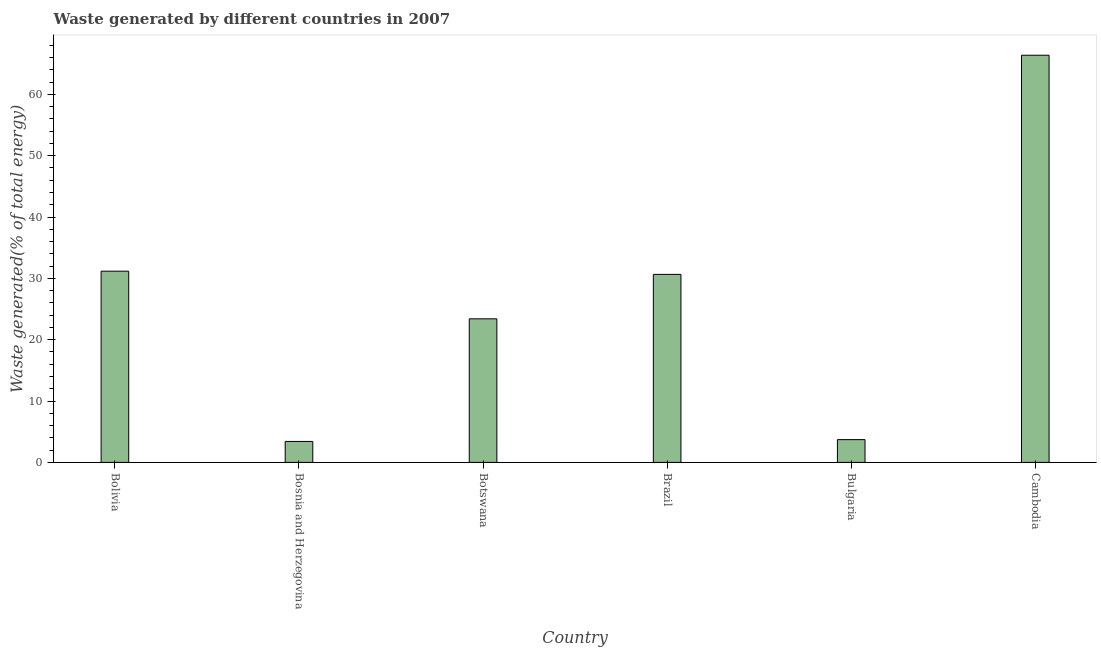Does the graph contain any zero values?
Your answer should be compact. No. Does the graph contain grids?
Provide a succinct answer. No. What is the title of the graph?
Make the answer very short. Waste generated by different countries in 2007. What is the label or title of the X-axis?
Provide a short and direct response. Country. What is the label or title of the Y-axis?
Your response must be concise. Waste generated(% of total energy). What is the amount of waste generated in Botswana?
Your response must be concise. 23.41. Across all countries, what is the maximum amount of waste generated?
Provide a short and direct response. 66.38. Across all countries, what is the minimum amount of waste generated?
Provide a succinct answer. 3.42. In which country was the amount of waste generated maximum?
Make the answer very short. Cambodia. In which country was the amount of waste generated minimum?
Make the answer very short. Bosnia and Herzegovina. What is the sum of the amount of waste generated?
Make the answer very short. 158.75. What is the difference between the amount of waste generated in Bosnia and Herzegovina and Bulgaria?
Your answer should be very brief. -0.29. What is the average amount of waste generated per country?
Provide a succinct answer. 26.46. What is the median amount of waste generated?
Offer a terse response. 27.03. In how many countries, is the amount of waste generated greater than 12 %?
Provide a short and direct response. 4. What is the ratio of the amount of waste generated in Bolivia to that in Bosnia and Herzegovina?
Provide a short and direct response. 9.13. Is the difference between the amount of waste generated in Brazil and Cambodia greater than the difference between any two countries?
Keep it short and to the point. No. What is the difference between the highest and the second highest amount of waste generated?
Make the answer very short. 35.2. What is the difference between the highest and the lowest amount of waste generated?
Keep it short and to the point. 62.97. Are the values on the major ticks of Y-axis written in scientific E-notation?
Make the answer very short. No. What is the Waste generated(% of total energy) of Bolivia?
Your response must be concise. 31.18. What is the Waste generated(% of total energy) of Bosnia and Herzegovina?
Offer a terse response. 3.42. What is the Waste generated(% of total energy) in Botswana?
Keep it short and to the point. 23.41. What is the Waste generated(% of total energy) of Brazil?
Make the answer very short. 30.65. What is the Waste generated(% of total energy) of Bulgaria?
Your answer should be compact. 3.71. What is the Waste generated(% of total energy) of Cambodia?
Keep it short and to the point. 66.38. What is the difference between the Waste generated(% of total energy) in Bolivia and Bosnia and Herzegovina?
Provide a succinct answer. 27.76. What is the difference between the Waste generated(% of total energy) in Bolivia and Botswana?
Your response must be concise. 7.77. What is the difference between the Waste generated(% of total energy) in Bolivia and Brazil?
Provide a short and direct response. 0.52. What is the difference between the Waste generated(% of total energy) in Bolivia and Bulgaria?
Make the answer very short. 27.47. What is the difference between the Waste generated(% of total energy) in Bolivia and Cambodia?
Your answer should be compact. -35.21. What is the difference between the Waste generated(% of total energy) in Bosnia and Herzegovina and Botswana?
Offer a terse response. -19.99. What is the difference between the Waste generated(% of total energy) in Bosnia and Herzegovina and Brazil?
Offer a very short reply. -27.24. What is the difference between the Waste generated(% of total energy) in Bosnia and Herzegovina and Bulgaria?
Keep it short and to the point. -0.29. What is the difference between the Waste generated(% of total energy) in Bosnia and Herzegovina and Cambodia?
Your answer should be very brief. -62.97. What is the difference between the Waste generated(% of total energy) in Botswana and Brazil?
Your answer should be very brief. -7.24. What is the difference between the Waste generated(% of total energy) in Botswana and Bulgaria?
Your answer should be very brief. 19.7. What is the difference between the Waste generated(% of total energy) in Botswana and Cambodia?
Make the answer very short. -42.97. What is the difference between the Waste generated(% of total energy) in Brazil and Bulgaria?
Your answer should be compact. 26.94. What is the difference between the Waste generated(% of total energy) in Brazil and Cambodia?
Give a very brief answer. -35.73. What is the difference between the Waste generated(% of total energy) in Bulgaria and Cambodia?
Offer a very short reply. -62.67. What is the ratio of the Waste generated(% of total energy) in Bolivia to that in Bosnia and Herzegovina?
Offer a very short reply. 9.13. What is the ratio of the Waste generated(% of total energy) in Bolivia to that in Botswana?
Offer a very short reply. 1.33. What is the ratio of the Waste generated(% of total energy) in Bolivia to that in Brazil?
Your answer should be very brief. 1.02. What is the ratio of the Waste generated(% of total energy) in Bolivia to that in Bulgaria?
Offer a very short reply. 8.4. What is the ratio of the Waste generated(% of total energy) in Bolivia to that in Cambodia?
Your answer should be very brief. 0.47. What is the ratio of the Waste generated(% of total energy) in Bosnia and Herzegovina to that in Botswana?
Keep it short and to the point. 0.15. What is the ratio of the Waste generated(% of total energy) in Bosnia and Herzegovina to that in Brazil?
Your answer should be very brief. 0.11. What is the ratio of the Waste generated(% of total energy) in Bosnia and Herzegovina to that in Bulgaria?
Offer a terse response. 0.92. What is the ratio of the Waste generated(% of total energy) in Bosnia and Herzegovina to that in Cambodia?
Your answer should be very brief. 0.05. What is the ratio of the Waste generated(% of total energy) in Botswana to that in Brazil?
Provide a short and direct response. 0.76. What is the ratio of the Waste generated(% of total energy) in Botswana to that in Bulgaria?
Ensure brevity in your answer.  6.31. What is the ratio of the Waste generated(% of total energy) in Botswana to that in Cambodia?
Your response must be concise. 0.35. What is the ratio of the Waste generated(% of total energy) in Brazil to that in Bulgaria?
Your answer should be compact. 8.26. What is the ratio of the Waste generated(% of total energy) in Brazil to that in Cambodia?
Offer a terse response. 0.46. What is the ratio of the Waste generated(% of total energy) in Bulgaria to that in Cambodia?
Provide a short and direct response. 0.06. 